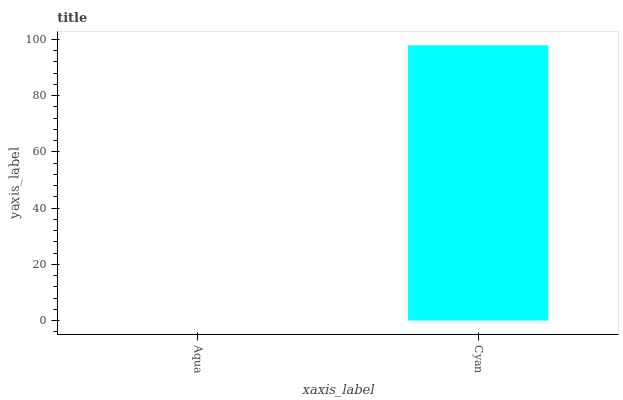Is Aqua the minimum?
Answer yes or no. Yes. Is Cyan the maximum?
Answer yes or no. Yes. Is Cyan the minimum?
Answer yes or no. No. Is Cyan greater than Aqua?
Answer yes or no. Yes. Is Aqua less than Cyan?
Answer yes or no. Yes. Is Aqua greater than Cyan?
Answer yes or no. No. Is Cyan less than Aqua?
Answer yes or no. No. Is Cyan the high median?
Answer yes or no. Yes. Is Aqua the low median?
Answer yes or no. Yes. Is Aqua the high median?
Answer yes or no. No. Is Cyan the low median?
Answer yes or no. No. 